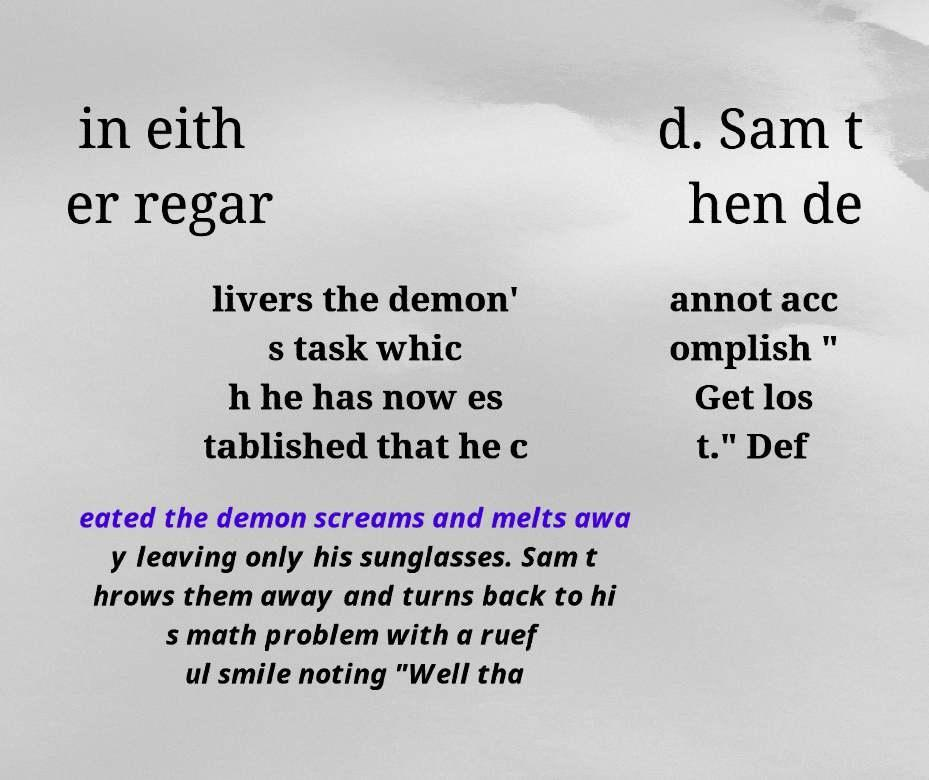Please read and relay the text visible in this image. What does it say? in eith er regar d. Sam t hen de livers the demon' s task whic h he has now es tablished that he c annot acc omplish " Get los t." Def eated the demon screams and melts awa y leaving only his sunglasses. Sam t hrows them away and turns back to hi s math problem with a ruef ul smile noting "Well tha 